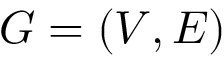<formula> <loc_0><loc_0><loc_500><loc_500>G = ( V , E )</formula> 